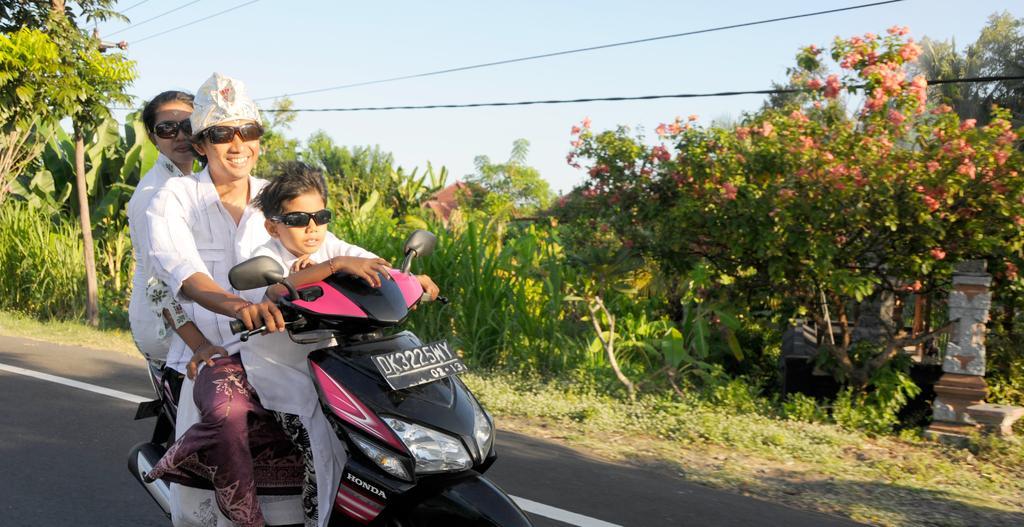How would you summarize this image in a sentence or two? There is a woman riding the Scooter and boy is sitting on it and a girl is sitting behind her and the right side of an image there are trees. Coming to the left side of an image there is a road. 